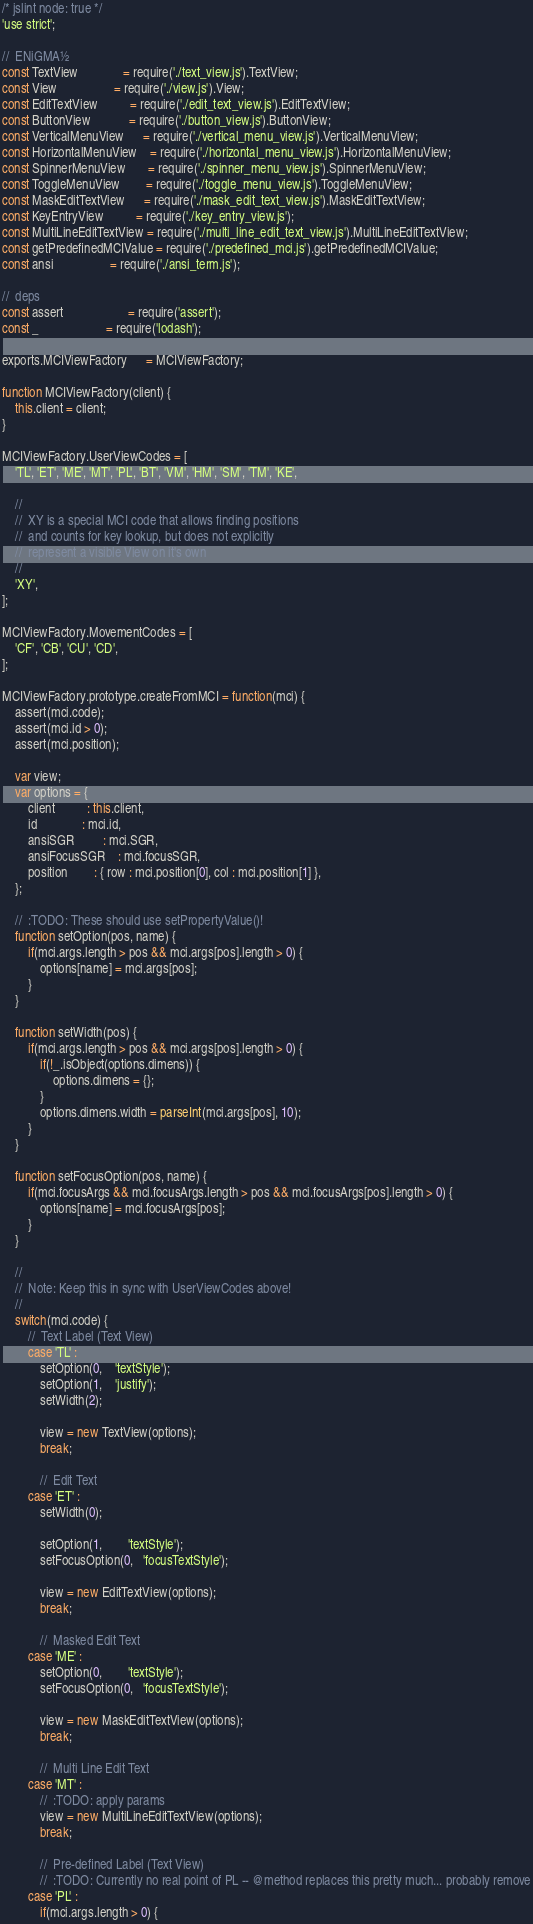<code> <loc_0><loc_0><loc_500><loc_500><_JavaScript_>/* jslint node: true */
'use strict';

//  ENiGMA½
const TextView              = require('./text_view.js').TextView;
const View                  = require('./view.js').View;
const EditTextView          = require('./edit_text_view.js').EditTextView;
const ButtonView            = require('./button_view.js').ButtonView;
const VerticalMenuView      = require('./vertical_menu_view.js').VerticalMenuView;
const HorizontalMenuView    = require('./horizontal_menu_view.js').HorizontalMenuView;
const SpinnerMenuView       = require('./spinner_menu_view.js').SpinnerMenuView;
const ToggleMenuView        = require('./toggle_menu_view.js').ToggleMenuView;
const MaskEditTextView      = require('./mask_edit_text_view.js').MaskEditTextView;
const KeyEntryView          = require('./key_entry_view.js');
const MultiLineEditTextView = require('./multi_line_edit_text_view.js').MultiLineEditTextView;
const getPredefinedMCIValue = require('./predefined_mci.js').getPredefinedMCIValue;
const ansi                  = require('./ansi_term.js');

//  deps
const assert                    = require('assert');
const _                     = require('lodash');

exports.MCIViewFactory      = MCIViewFactory;

function MCIViewFactory(client) {
    this.client = client;
}

MCIViewFactory.UserViewCodes = [
    'TL', 'ET', 'ME', 'MT', 'PL', 'BT', 'VM', 'HM', 'SM', 'TM', 'KE',

    //
    //  XY is a special MCI code that allows finding positions
    //  and counts for key lookup, but does not explicitly
    //  represent a visible View on it's own
    //
    'XY',
];

MCIViewFactory.MovementCodes = [
    'CF', 'CB', 'CU', 'CD',
];

MCIViewFactory.prototype.createFromMCI = function(mci) {
    assert(mci.code);
    assert(mci.id > 0);
    assert(mci.position);

    var view;
    var options = {
        client          : this.client,
        id              : mci.id,
        ansiSGR         : mci.SGR,
        ansiFocusSGR    : mci.focusSGR,
        position        : { row : mci.position[0], col : mci.position[1] },
    };

    //  :TODO: These should use setPropertyValue()!
    function setOption(pos, name) {
        if(mci.args.length > pos && mci.args[pos].length > 0) {
            options[name] = mci.args[pos];
        }
    }

    function setWidth(pos) {
        if(mci.args.length > pos && mci.args[pos].length > 0) {
            if(!_.isObject(options.dimens)) {
                options.dimens = {};
            }
            options.dimens.width = parseInt(mci.args[pos], 10);
        }
    }

    function setFocusOption(pos, name) {
        if(mci.focusArgs && mci.focusArgs.length > pos && mci.focusArgs[pos].length > 0) {
            options[name] = mci.focusArgs[pos];
        }
    }

    //
    //  Note: Keep this in sync with UserViewCodes above!
    //
    switch(mci.code) {
        //  Text Label (Text View)
        case 'TL' :
            setOption(0,    'textStyle');
            setOption(1,    'justify');
            setWidth(2);

            view = new TextView(options);
            break;

            //  Edit Text
        case 'ET' :
            setWidth(0);

            setOption(1,        'textStyle');
            setFocusOption(0,   'focusTextStyle');

            view = new EditTextView(options);
            break;

            //  Masked Edit Text
        case 'ME' :
            setOption(0,        'textStyle');
            setFocusOption(0,   'focusTextStyle');

            view = new MaskEditTextView(options);
            break;

            //  Multi Line Edit Text
        case 'MT' :
            //  :TODO: apply params
            view = new MultiLineEditTextView(options);
            break;

            //  Pre-defined Label (Text View)
            //  :TODO: Currently no real point of PL -- @method replaces this pretty much... probably remove
        case 'PL' :
            if(mci.args.length > 0) {</code> 